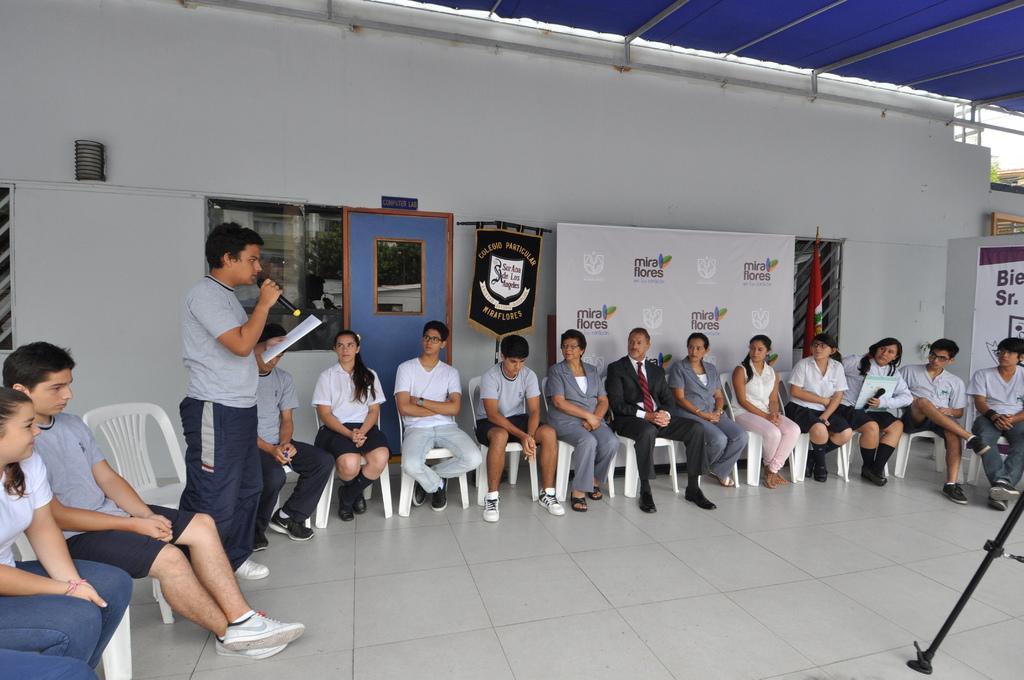Could you give a brief overview of what you see in this image? In this image, on the left there is a man, he wears a t shirt, trouser, shoes, he is holding a mic, papers. In the middle there are many people, they are sitting on the chairs. At the bottom there is stand, floor. In the background there are banners, posters, window, door, flag, shed, wall, sky. 